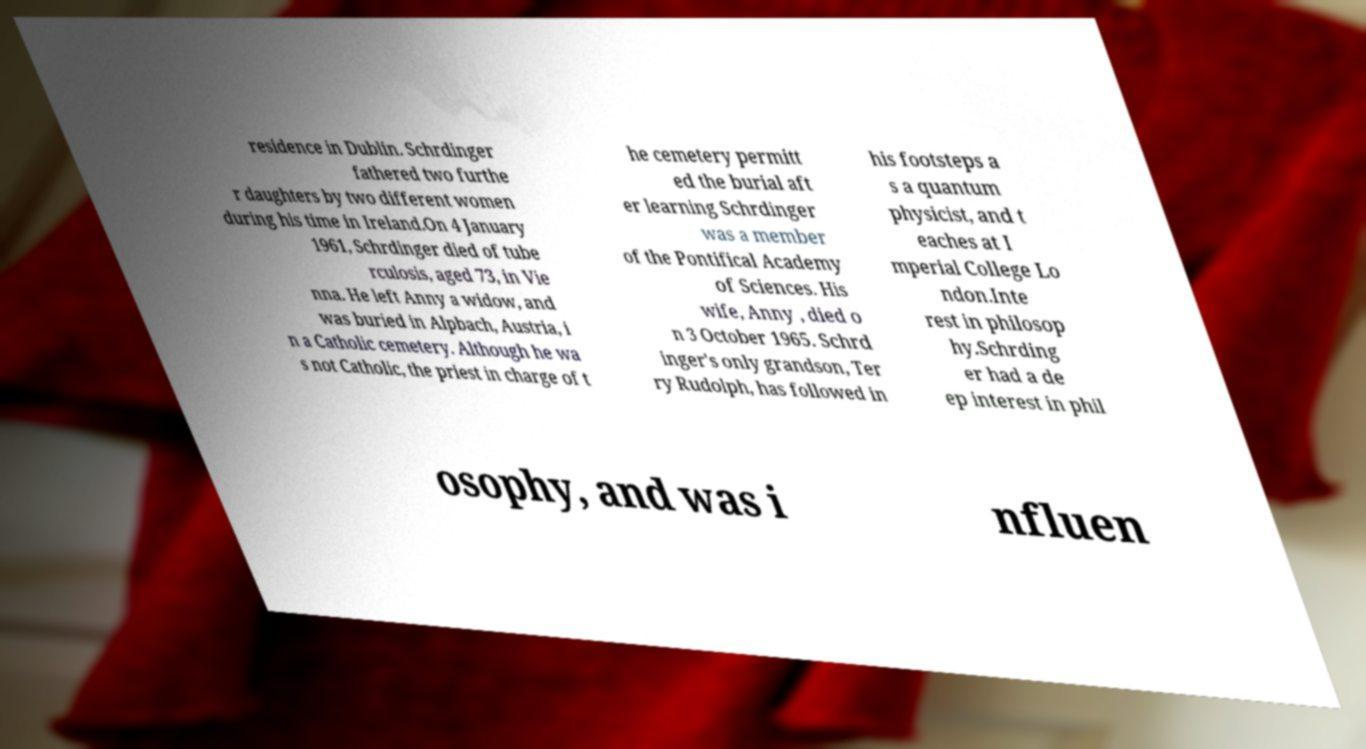Please identify and transcribe the text found in this image. residence in Dublin. Schrdinger fathered two furthe r daughters by two different women during his time in Ireland.On 4 January 1961, Schrdinger died of tube rculosis, aged 73, in Vie nna. He left Anny a widow, and was buried in Alpbach, Austria, i n a Catholic cemetery. Although he wa s not Catholic, the priest in charge of t he cemetery permitt ed the burial aft er learning Schrdinger was a member of the Pontifical Academy of Sciences. His wife, Anny , died o n 3 October 1965. Schrd inger's only grandson, Ter ry Rudolph, has followed in his footsteps a s a quantum physicist, and t eaches at I mperial College Lo ndon.Inte rest in philosop hy.Schrding er had a de ep interest in phil osophy, and was i nfluen 